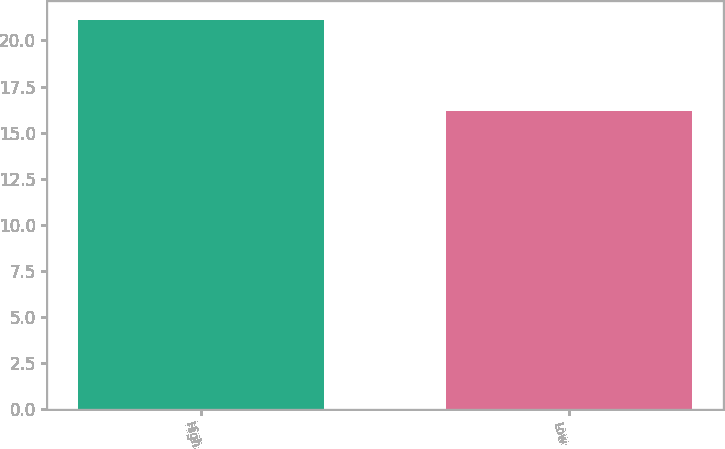Convert chart to OTSL. <chart><loc_0><loc_0><loc_500><loc_500><bar_chart><fcel>High<fcel>Low<nl><fcel>21.1<fcel>16.2<nl></chart> 